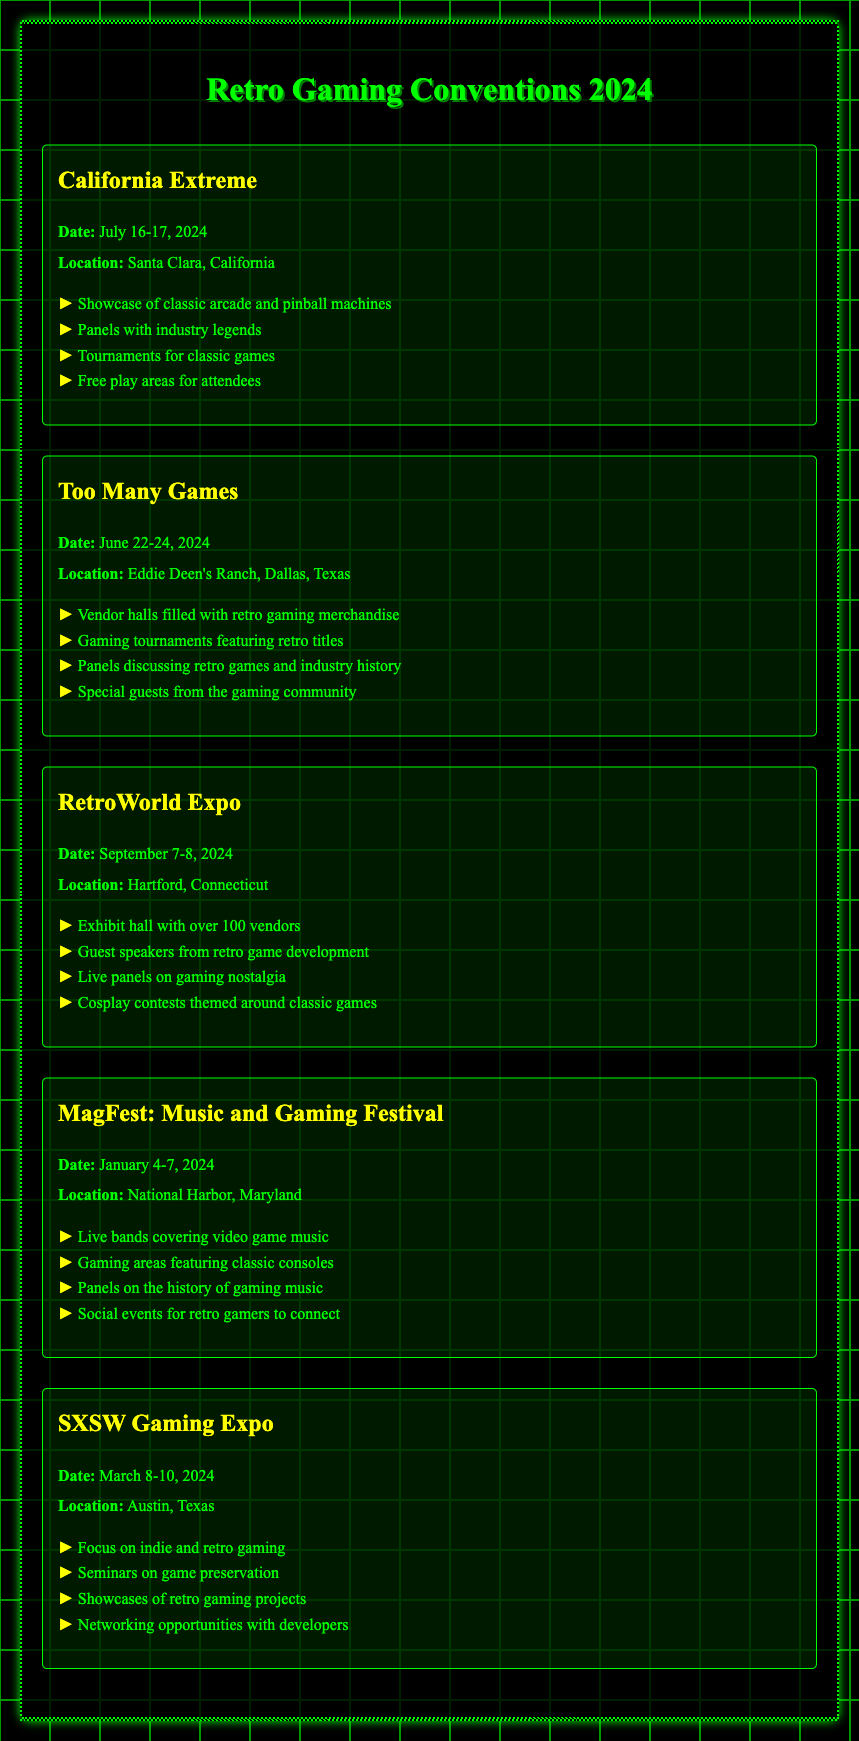What is the name of the convention in Santa Clara? The convention in Santa Clara is "California Extreme".
Answer: California Extreme When does the RetroWorld Expo take place? The RetroWorld Expo takes place on September 7-8, 2024.
Answer: September 7-8, 2024 What location will host the MagFest event? The MagFest event will be held in National Harbor, Maryland.
Answer: National Harbor, Maryland Which convention features panels with industry legends? The convention featuring panels with industry legends is "California Extreme".
Answer: California Extreme How many days does Too Many Games last? Too Many Games lasts for three days, from June 22-24, 2024.
Answer: Three days What is a featured activity at SXSW Gaming Expo? A featured activity at SXSW Gaming Expo is "seminars on game preservation".
Answer: Seminars on game preservation Which event includes cosplay contests? The event that includes cosplay contests is "RetroWorld Expo".
Answer: RetroWorld Expo When is the date range for the SXSW Gaming Expo? The date range for the SXSW Gaming Expo is March 8-10, 2024.
Answer: March 8-10, 2024 What state is the RetroWorld Expo located in? The RetroWorld Expo is located in Connecticut.
Answer: Connecticut 